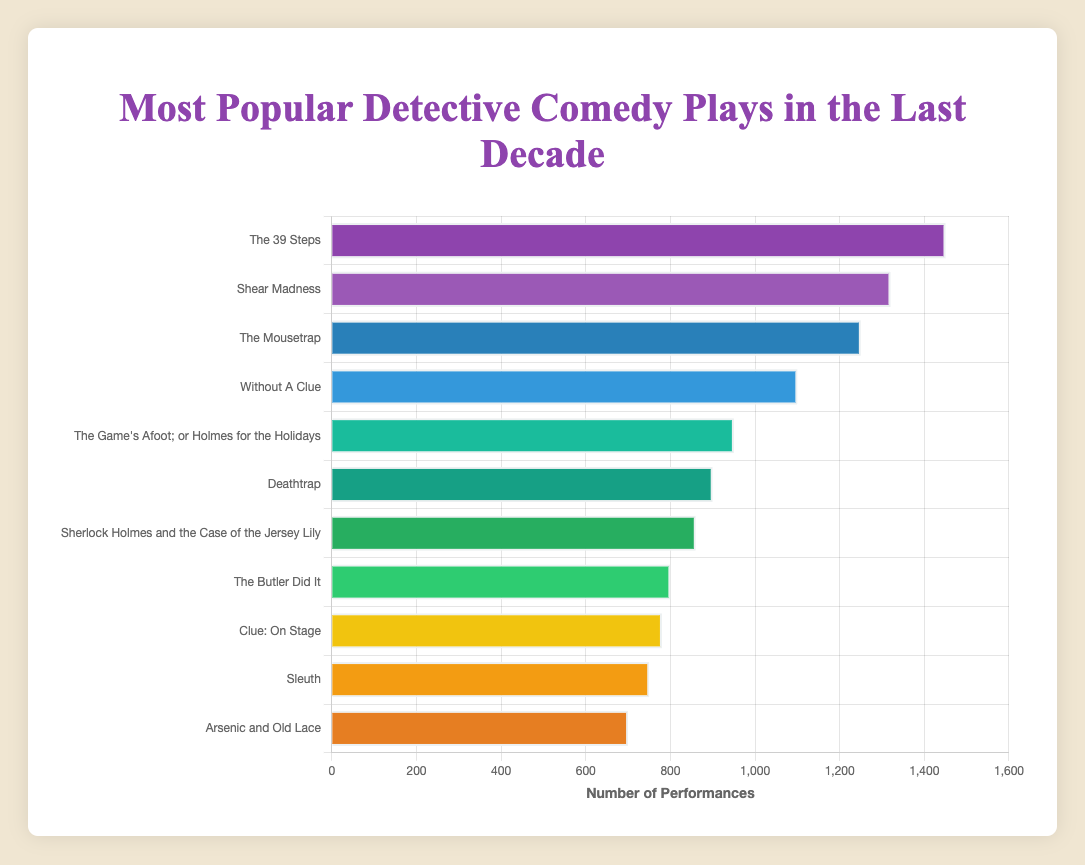What's the title of the play with the highest number of performances? The figure shows "The 39 Steps" at the top with 1450 performances, which is the highest among all the listed plays.
Answer: The 39 Steps Which play had the least number of performances in the past decade? Looking at the bottom of the chart, "Arsenic and Old Lace" has the fewest performances at 700.
Answer: Arsenic and Old Lace What’s the difference in the number of performances between "The Mousetrap" and "Clue: On Stage"? "The Mousetrap" has 1250 performances, and "Clue: On Stage" has 780. The difference is 1250 - 780 = 470 performances.
Answer: 470 How many plays had more than 1000 performances? From the chart, "The 39 Steps," "Shear Madness," "The Mousetrap," and "Without A Clue" had more than 1000 performances. That’s a total of 4 plays.
Answer: 4 On average, how many performances did the top 3 plays have? The top 3 plays are "The 39 Steps" (1450), "Shear Madness" (1320), and "The Mousetrap" (1250). The total is 1450 + 1320 + 1250 = 4020. The average is 4020 / 3 = 1340 performances.
Answer: 1340 Which play had more performances: "Deathtrap" or "Sleuth"? According to the chart, "Deathtrap" had 900 performances and "Sleuth" had 750 performances. Therefore, "Deathtrap" had more performances.
Answer: Deathtrap What is the combined number of performances for "The Butler Did It" and "Sherlock Holmes and the Case of the Jersey Lily"? Adding the performances of "The Butler Did It" (800) and "Sherlock Holmes and the Case of the Jersey Lily" (860) gives 800 + 860 = 1660 performances.
Answer: 1660 Which play had more performances, "Without A Clue" or "The Game's Afoot; or Holmes for the Holidays," and by what margin? "Without A Clue" had 1100 performances, while "The Game's Afoot; or Holmes for the Holidays" had 950 performances. The margin is 1100 - 950 = 150 performances.
Answer: Without A Clue by 150 Identify the play with a green-colored bar. The chart shows the green-colored bar corresponding to "The Game's Afoot; or Holmes for the Holidays" with 950 performances.
Answer: The Game's Afoot; or Holmes for the Holidays 